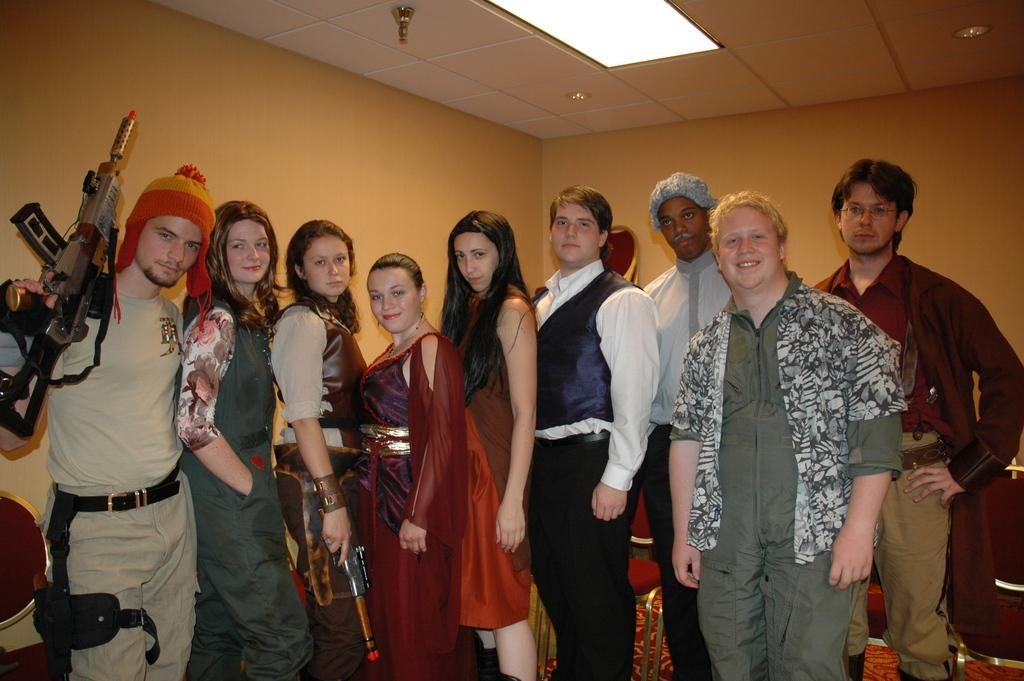What are the people in the foreground of the image doing? The persons in the foreground of the image are standing and posing to the camera. What can be seen in the background of the image? There is a wall, a ceiling, lights, and chairs in the background of the image. What type of sign can be seen hanging from the ceiling in the image? There is no sign hanging from the ceiling in the image; only lights and chairs are present in the background. 